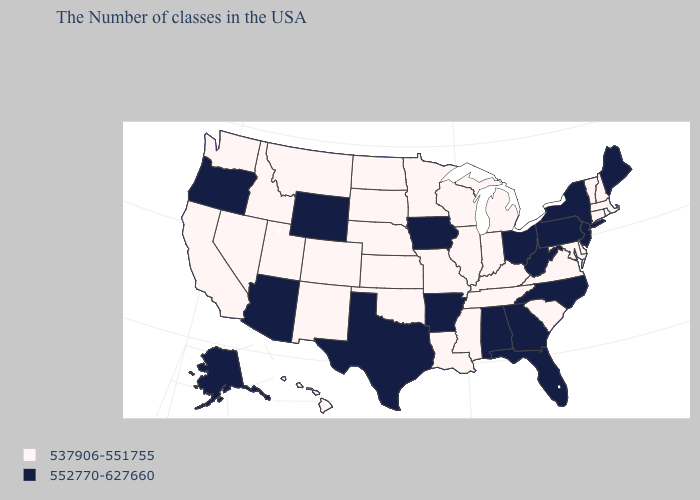Does Massachusetts have a higher value than Rhode Island?
Keep it brief. No. Among the states that border Nebraska , which have the lowest value?
Be succinct. Missouri, Kansas, South Dakota, Colorado. Is the legend a continuous bar?
Quick response, please. No. What is the value of Maine?
Quick response, please. 552770-627660. What is the value of Washington?
Concise answer only. 537906-551755. What is the value of Oregon?
Write a very short answer. 552770-627660. Which states have the lowest value in the West?
Write a very short answer. Colorado, New Mexico, Utah, Montana, Idaho, Nevada, California, Washington, Hawaii. Name the states that have a value in the range 537906-551755?
Be succinct. Massachusetts, Rhode Island, New Hampshire, Vermont, Connecticut, Delaware, Maryland, Virginia, South Carolina, Michigan, Kentucky, Indiana, Tennessee, Wisconsin, Illinois, Mississippi, Louisiana, Missouri, Minnesota, Kansas, Nebraska, Oklahoma, South Dakota, North Dakota, Colorado, New Mexico, Utah, Montana, Idaho, Nevada, California, Washington, Hawaii. Does Massachusetts have the highest value in the USA?
Write a very short answer. No. What is the highest value in states that border Vermont?
Write a very short answer. 552770-627660. What is the lowest value in the USA?
Short answer required. 537906-551755. Name the states that have a value in the range 537906-551755?
Concise answer only. Massachusetts, Rhode Island, New Hampshire, Vermont, Connecticut, Delaware, Maryland, Virginia, South Carolina, Michigan, Kentucky, Indiana, Tennessee, Wisconsin, Illinois, Mississippi, Louisiana, Missouri, Minnesota, Kansas, Nebraska, Oklahoma, South Dakota, North Dakota, Colorado, New Mexico, Utah, Montana, Idaho, Nevada, California, Washington, Hawaii. Does Vermont have a lower value than Iowa?
Write a very short answer. Yes. How many symbols are there in the legend?
Concise answer only. 2. Does the map have missing data?
Short answer required. No. 